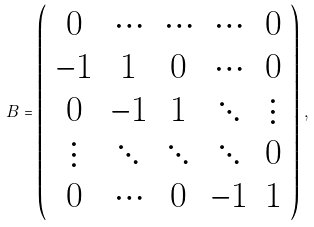Convert formula to latex. <formula><loc_0><loc_0><loc_500><loc_500>B = \left ( \begin{array} { c c c c c } 0 & \cdots & \cdots & \cdots & 0 \\ - 1 & 1 & 0 & \cdots & 0 \\ 0 & - 1 & 1 & \ddots & \vdots \\ \vdots & \ddots & \ddots & \ddots & 0 \\ 0 & \cdots & 0 & - 1 & 1 \end{array} \right ) \, ,</formula> 